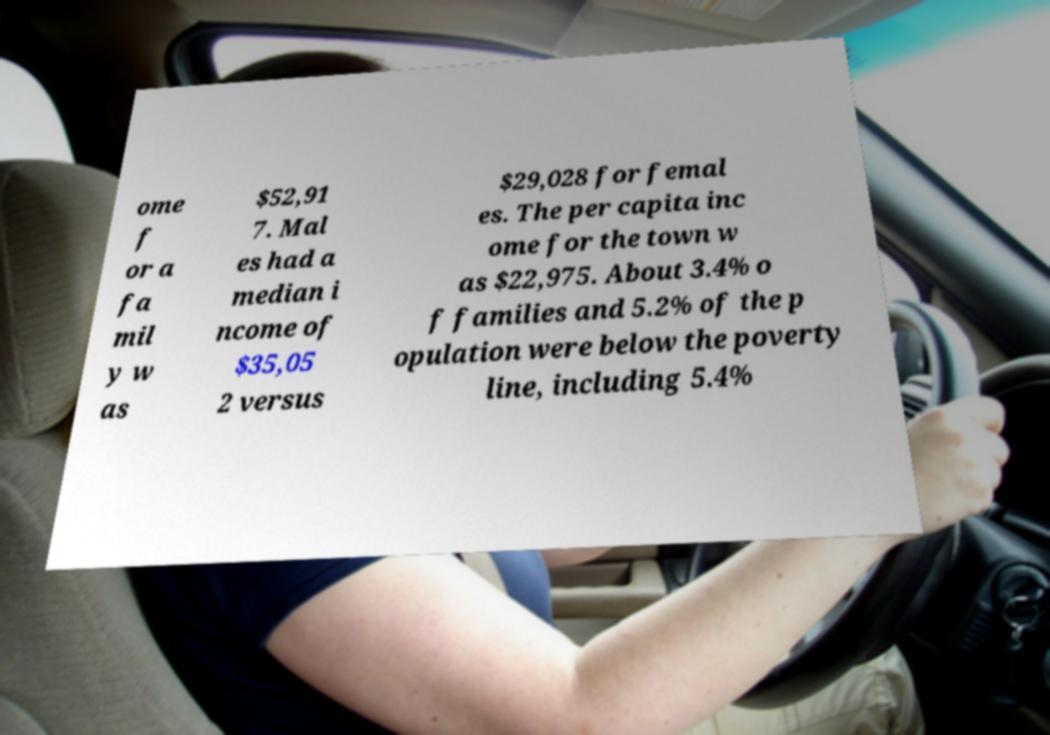Please identify and transcribe the text found in this image. ome f or a fa mil y w as $52,91 7. Mal es had a median i ncome of $35,05 2 versus $29,028 for femal es. The per capita inc ome for the town w as $22,975. About 3.4% o f families and 5.2% of the p opulation were below the poverty line, including 5.4% 